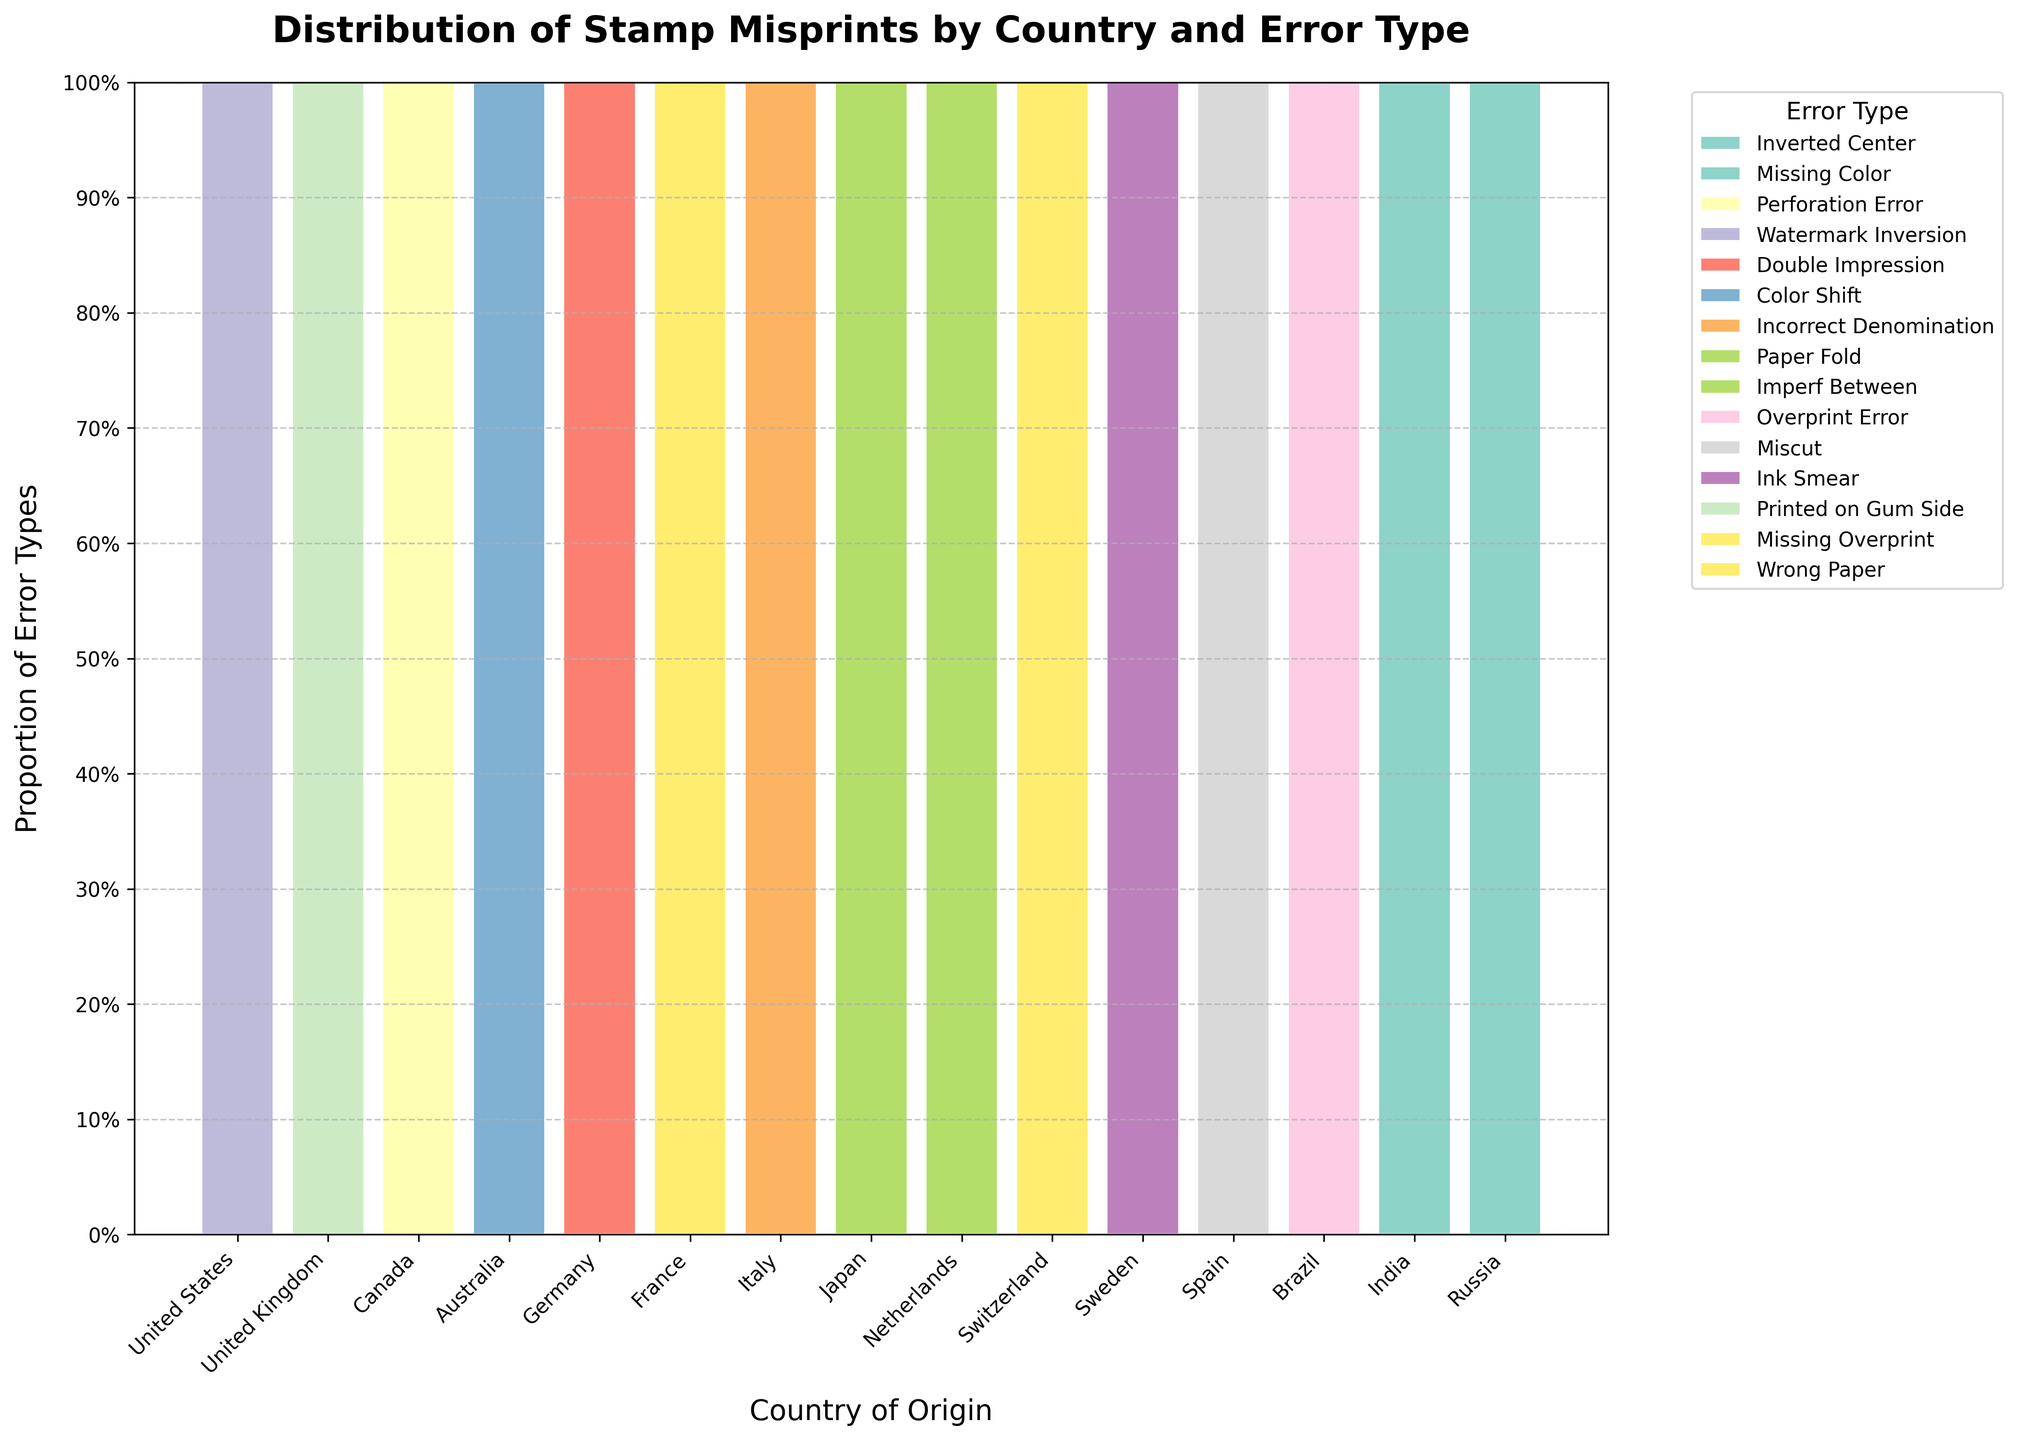What is the title of the plot? The title is displayed at the top of the plot and is typically larger and bolder than other text.
Answer: Distribution of Stamp Misprints by Country and Error Type Which country has the highest proportion of 'Perforation Error'? Look at the height of the segment labeled 'Perforation Error' for each country. The tallest segment indicates the highest proportion.
Answer: Canada What is the total number of countries displayed in the plot? Count the number of unique regions along the x-axis, each representing a country.
Answer: 15 Which error type has the largest segment across any country? Identify the segments with the largest area under any country, indicating the highest proportions.
Answer: Perforation Error in Canada Which two countries have an equal proportion of 'Ink Smear' errors? Compare the heights of the segments for 'Ink Smear' across different countries, and identify those that are equal.
Answer: Australia and Spain Which country has the smallest cumulative proportion of all error types? Evaluate the cumulative proportions (sum of segment heights) for each country and identify the smallest one.
Answer: Brazil How does the proportion of 'Inverted Center' error in the United States compare with the 'Wrong Paper' error in Russia? Analyze the heights of the 'Inverted Center' segment in the United States and the 'Wrong Paper' segment in Russia.
Answer: Inverted Center in the United States is higher What proportion of errors in France are 'Color Shift' errors? Measure the height of the 'Color Shift' segment in France relative to the total height for France. The total height for each country is always equal to 1.
Answer: Approximately 35% Is there any country with a high proportion of 'Overprint Error' higher than 'Missing Color'? Compare the height of 'Overprint Error' segments against 'Missing Color' segments across all countries.
Answer: Switzerland with 'Overprint Error' higher than 'Missing Color' Which countries have a misprint error type that is nearly 50% of their errors? Look for segments that occupy nearly half of the vertical bar within a country, indicating about 50% proportion.
Answer: Canada and Germany 